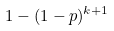Convert formula to latex. <formula><loc_0><loc_0><loc_500><loc_500>1 - ( 1 - p ) ^ { k + 1 }</formula> 